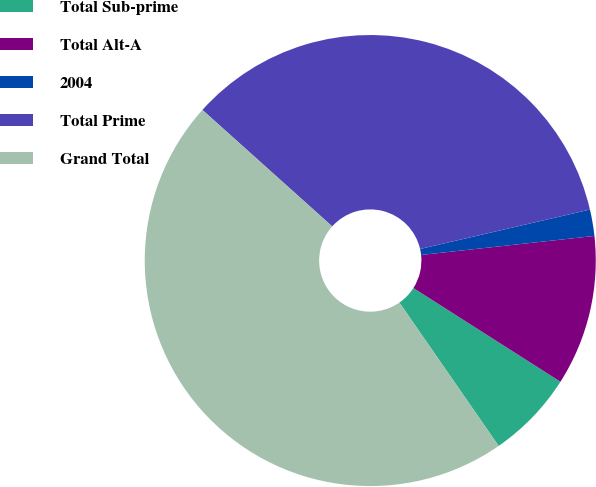Convert chart to OTSL. <chart><loc_0><loc_0><loc_500><loc_500><pie_chart><fcel>Total Sub-prime<fcel>Total Alt-A<fcel>2004<fcel>Total Prime<fcel>Grand Total<nl><fcel>6.33%<fcel>10.77%<fcel>1.89%<fcel>34.73%<fcel>46.28%<nl></chart> 